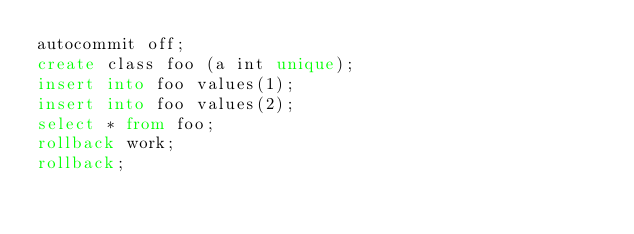<code> <loc_0><loc_0><loc_500><loc_500><_SQL_>autocommit off;
create class foo (a int unique);
insert into foo values(1);
insert into foo values(2);
select * from foo;
rollback work;
rollback;
</code> 